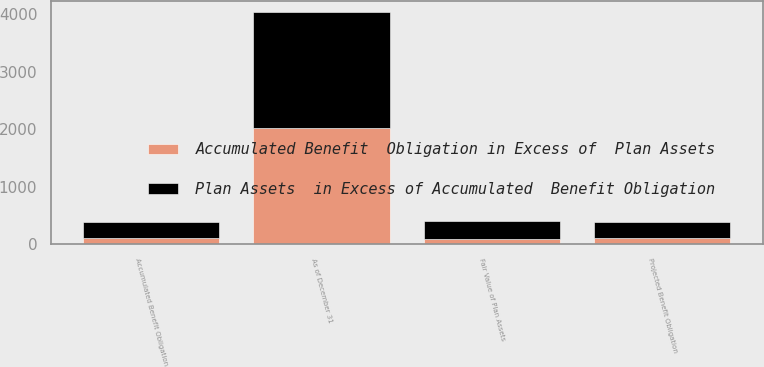Convert chart. <chart><loc_0><loc_0><loc_500><loc_500><stacked_bar_chart><ecel><fcel>As of December 31<fcel>Projected Benefit Obligation<fcel>Accumulated Benefit Obligation<fcel>Fair Value of Plan Assets<nl><fcel>Plan Assets  in Excess of Accumulated  Benefit Obligation<fcel>2017<fcel>287<fcel>283<fcel>312<nl><fcel>Accumulated Benefit  Obligation in Excess of  Plan Assets<fcel>2017<fcel>104<fcel>104<fcel>91<nl></chart> 